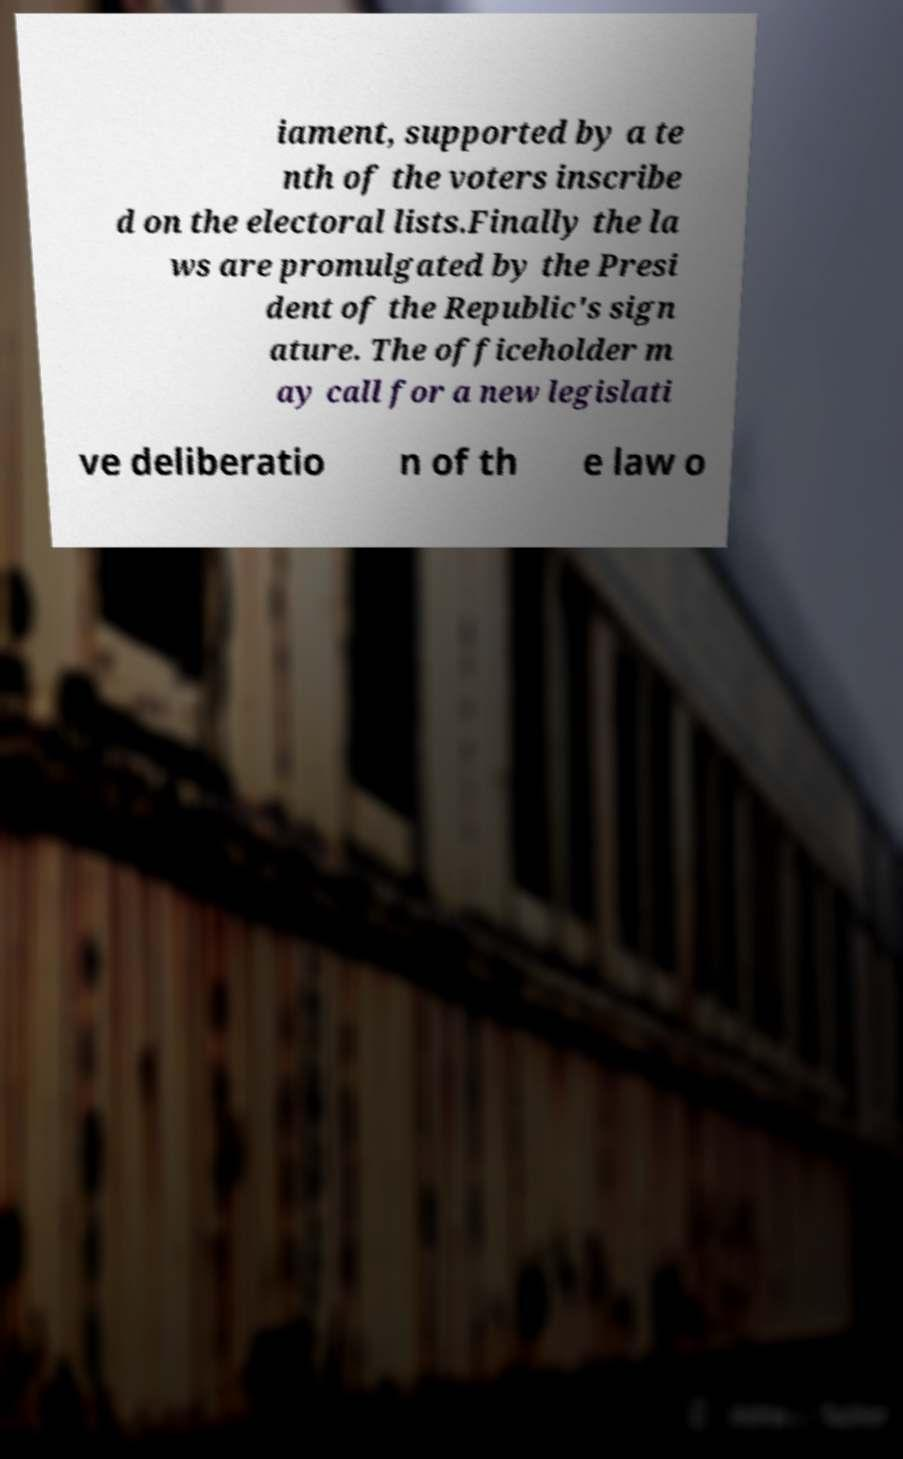Please identify and transcribe the text found in this image. iament, supported by a te nth of the voters inscribe d on the electoral lists.Finally the la ws are promulgated by the Presi dent of the Republic's sign ature. The officeholder m ay call for a new legislati ve deliberatio n of th e law o 